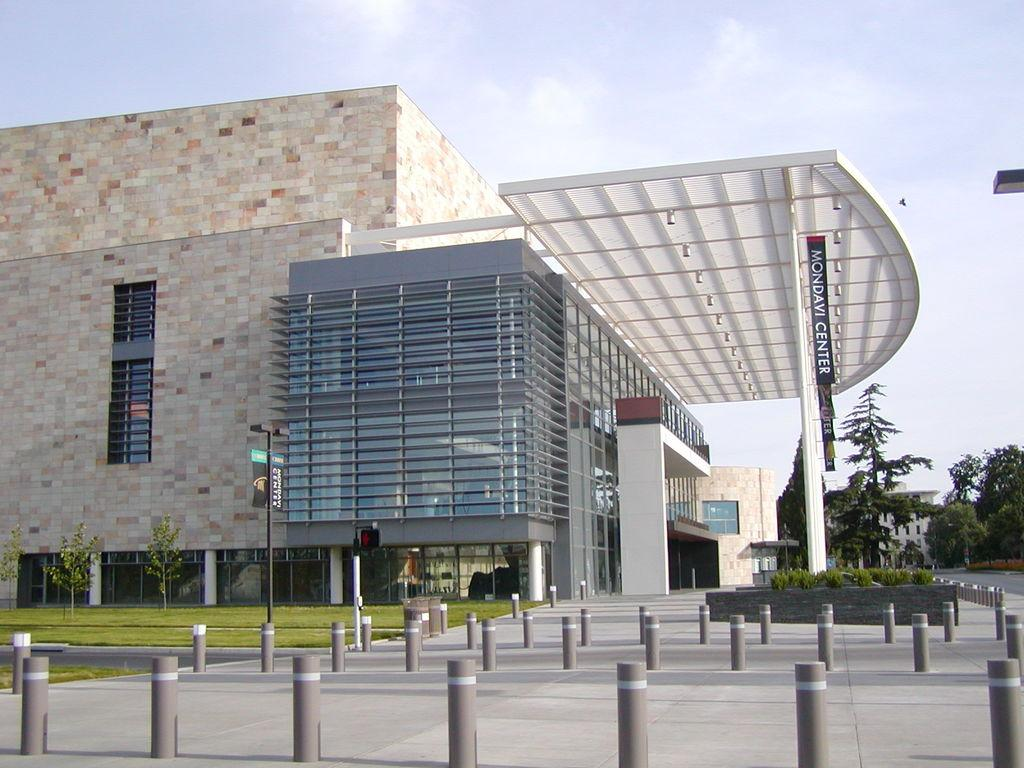What is the main subject in the center of the image? There is a building in the center of the image. What type of natural environment is visible in the image? There is greenery in the image. What are the vertical structures in the image? There are poles in the image. What type of notebook is the woman holding in the image? There is no woman or notebook present in the image. 